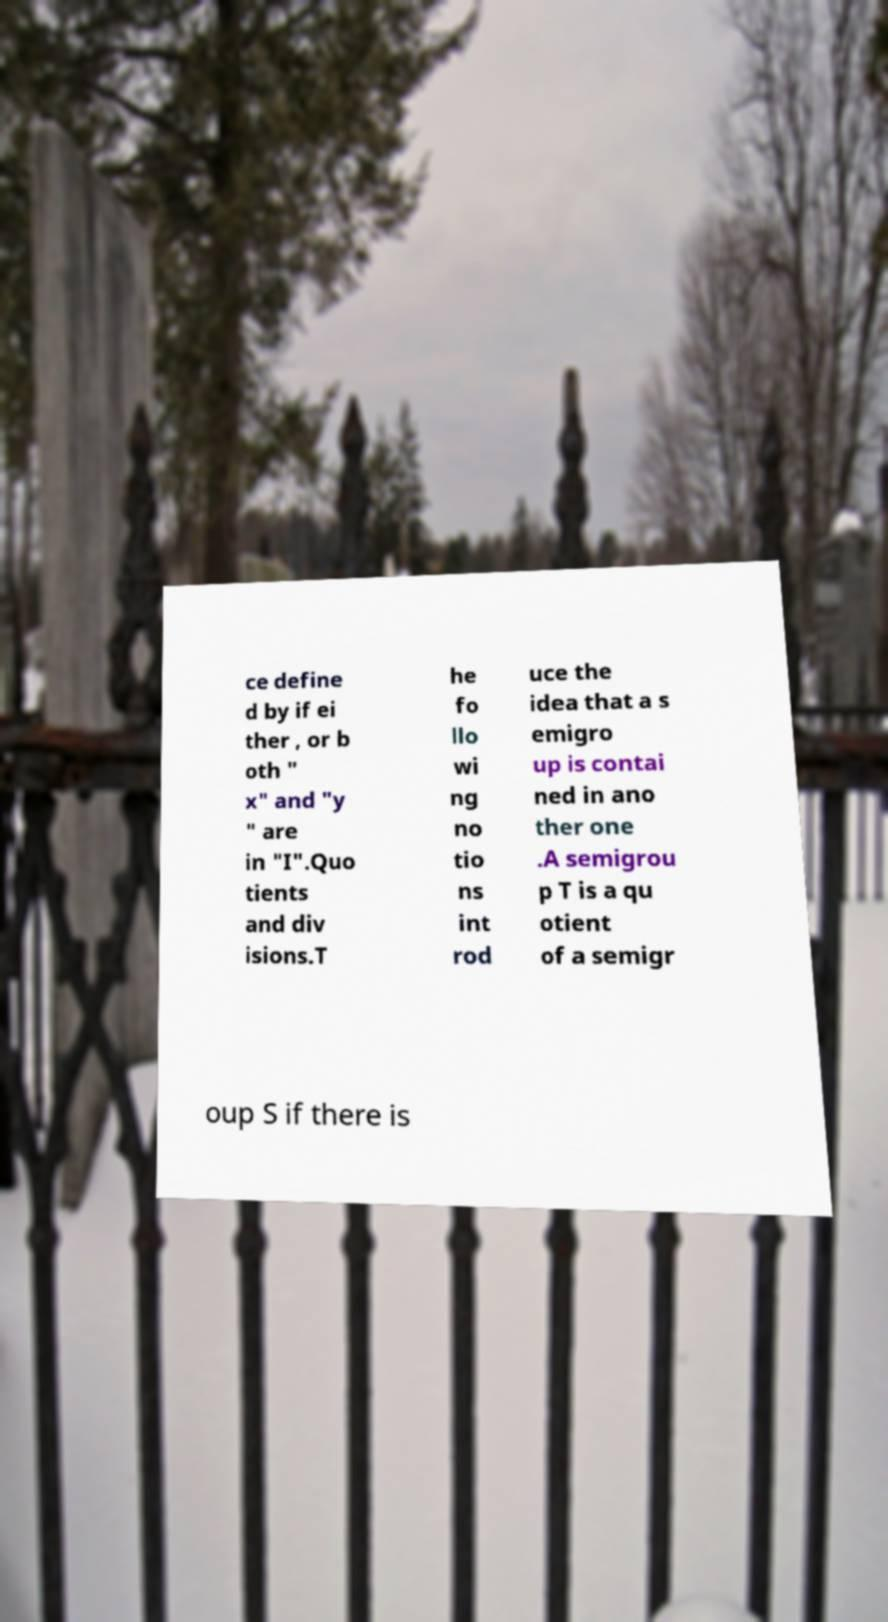What messages or text are displayed in this image? I need them in a readable, typed format. ce define d by if ei ther , or b oth " x" and "y " are in "I".Quo tients and div isions.T he fo llo wi ng no tio ns int rod uce the idea that a s emigro up is contai ned in ano ther one .A semigrou p T is a qu otient of a semigr oup S if there is 